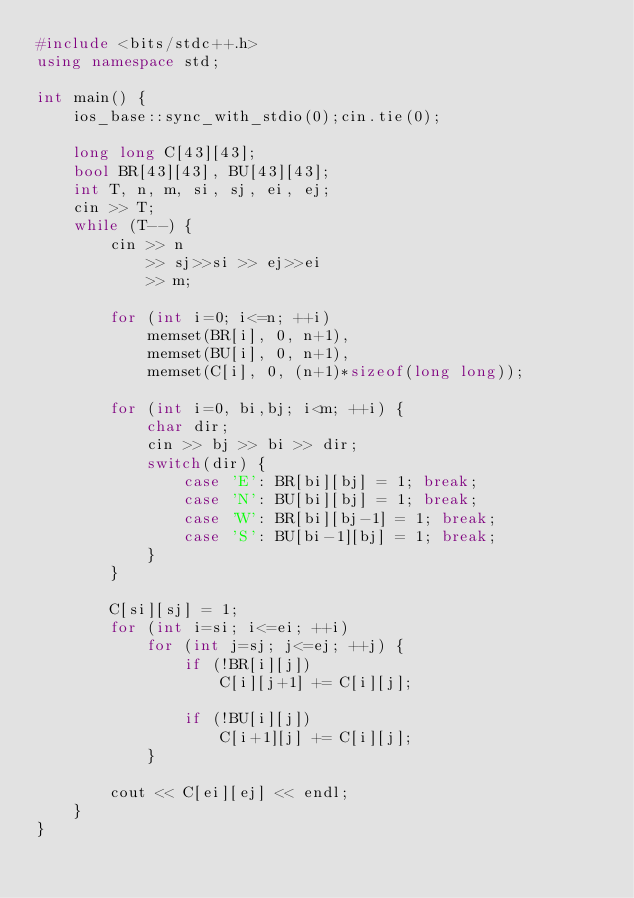<code> <loc_0><loc_0><loc_500><loc_500><_C++_>#include <bits/stdc++.h>
using namespace std;

int main() {
    ios_base::sync_with_stdio(0);cin.tie(0);

    long long C[43][43];
    bool BR[43][43], BU[43][43];
    int T, n, m, si, sj, ei, ej;
    cin >> T;
    while (T--) {
        cin >> n
            >> sj>>si >> ej>>ei
            >> m;

        for (int i=0; i<=n; ++i)
            memset(BR[i], 0, n+1),
            memset(BU[i], 0, n+1),
            memset(C[i], 0, (n+1)*sizeof(long long));

        for (int i=0, bi,bj; i<m; ++i) {
            char dir;
            cin >> bj >> bi >> dir;
            switch(dir) {
                case 'E': BR[bi][bj] = 1; break;
                case 'N': BU[bi][bj] = 1; break;
                case 'W': BR[bi][bj-1] = 1; break;
                case 'S': BU[bi-1][bj] = 1; break;
            }
        }

        C[si][sj] = 1;
        for (int i=si; i<=ei; ++i)
            for (int j=sj; j<=ej; ++j) {
                if (!BR[i][j])
                    C[i][j+1] += C[i][j];

                if (!BU[i][j])
                    C[i+1][j] += C[i][j];
            }

        cout << C[ei][ej] << endl;
    }
}
</code> 